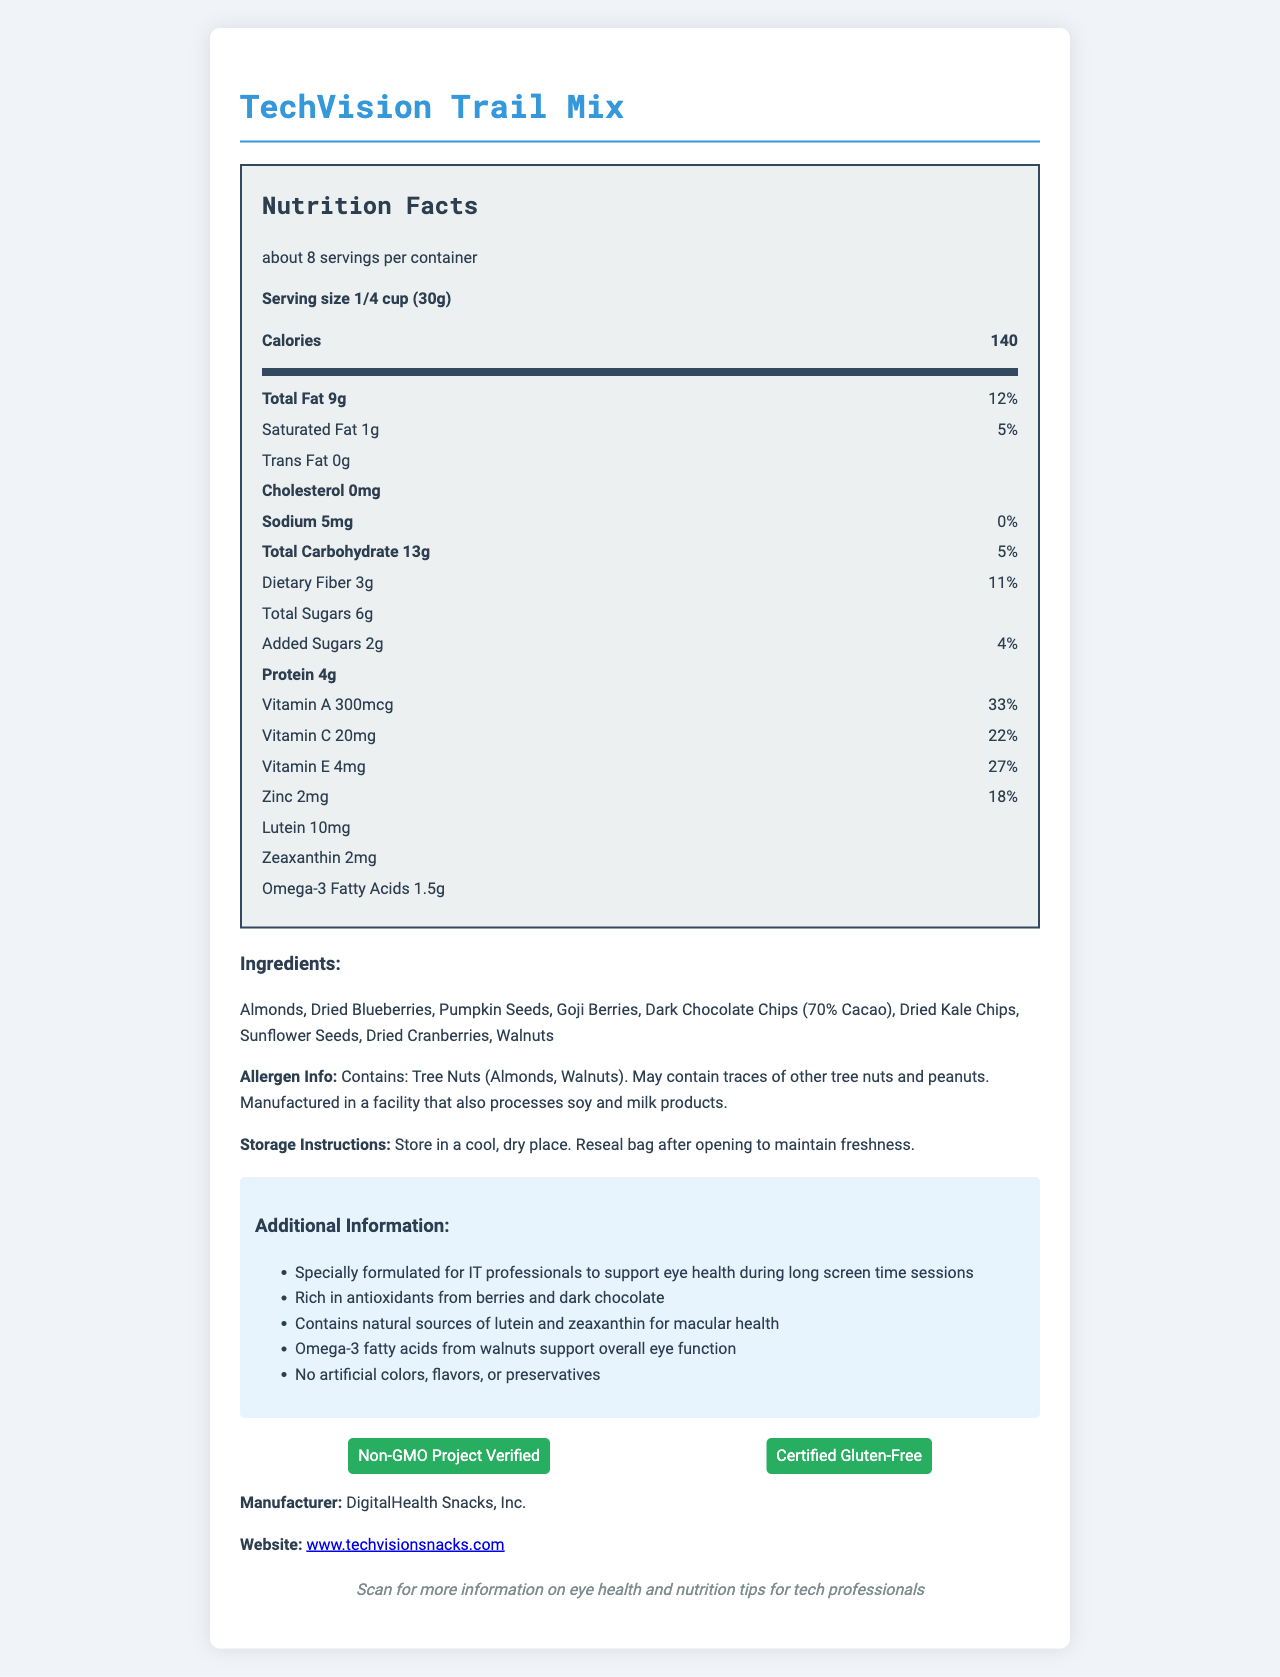what is the product name? The product name is given at the top of the document as TechVision Trail Mix.
Answer: TechVision Trail Mix what is the serving size? The serving size is specified as 1/4 cup (30g).
Answer: 1/4 cup (30g) how many servings are there per container? The document states that there are about 8 servings per container.
Answer: about 8 what is the amount of calories per serving? The nutrition label shows that each serving contains 140 calories.
Answer: 140 how much total fat is in one serving? The document states that there are 9 grams of total fat per serving.
Answer: 9g how much dietary fiber does one serving of TechVision Trail Mix provide? The dietary fiber content per serving is listed as 3 grams.
Answer: 3g what is the daily value percentage for vitamin A in one serving? The daily value percentage for vitamin A is given as 33%.
Answer: 33% what kind of fat is 0 grams in TechVision Trail Mix? A. Saturated Fat B. Trans Fat C. Omega-3 Fatty Acids The document shows that trans fat is 0 grams per serving.
Answer: B. Trans Fat which ingredient is not listed in TechVision Trail Mix? A. Almonds B. Sunflower Seeds C. Cashews D. Dried Cranberries Cashews are not mentioned in the ingredients list.
Answer: C. Cashews does the product contain any common allergens? The allergen information specifies that the product contains tree nuts (almonds and walnuts) and may contain traces of other tree nuts and peanuts.
Answer: Yes is TechVision Trail Mix suitable for gluten-intolerant individuals? The document includes a Certified Gluten-Free certification.
Answer: Yes what additional nutrients support eye health in TechVision Trail Mix? The document highlights natural sources of lutein and zeaxanthin for macular health.
Answer: lutein, zeaxanthin what storage instructions are provided for TechVision Trail Mix? The storage instructions are to keep the product in a cool, dry place and reseal the bag after opening.
Answer: Store in a cool, dry place. Reseal bag after opening to maintain freshness. who is the manufacturer of TechVision Trail Mix? The manufacturer is stated as DigitalHealth Snacks, Inc.
Answer: DigitalHealth Snacks, Inc. summarize the main idea of this document. The document highlights the nutritional content, health benefits, ingredient list, allergen information, storage instructions, manufacturer details, and certifications related to TechVision Trail Mix.
Answer: The document provides the nutritional information, ingredients, and certifications for TechVision Trail Mix, a trail mix formulated to support eye health during long screen sessions for IT professionals. what is the origin of the pumpkin seeds used in TechVision Trail Mix? The ingredient list includes pumpkin seeds, but their origin is not provided in the document.
Answer: Not enough information 